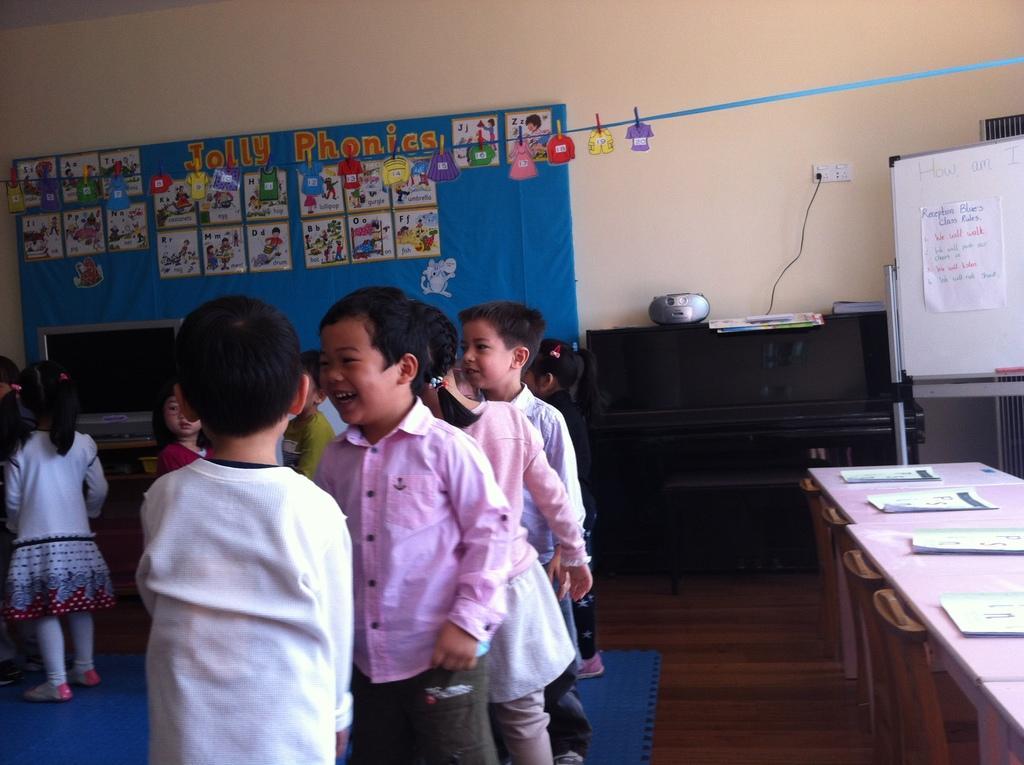Can you describe this image briefly? In this picture we can see a group of children on the floor, here we can see boards, wall, monitor and some objects. 